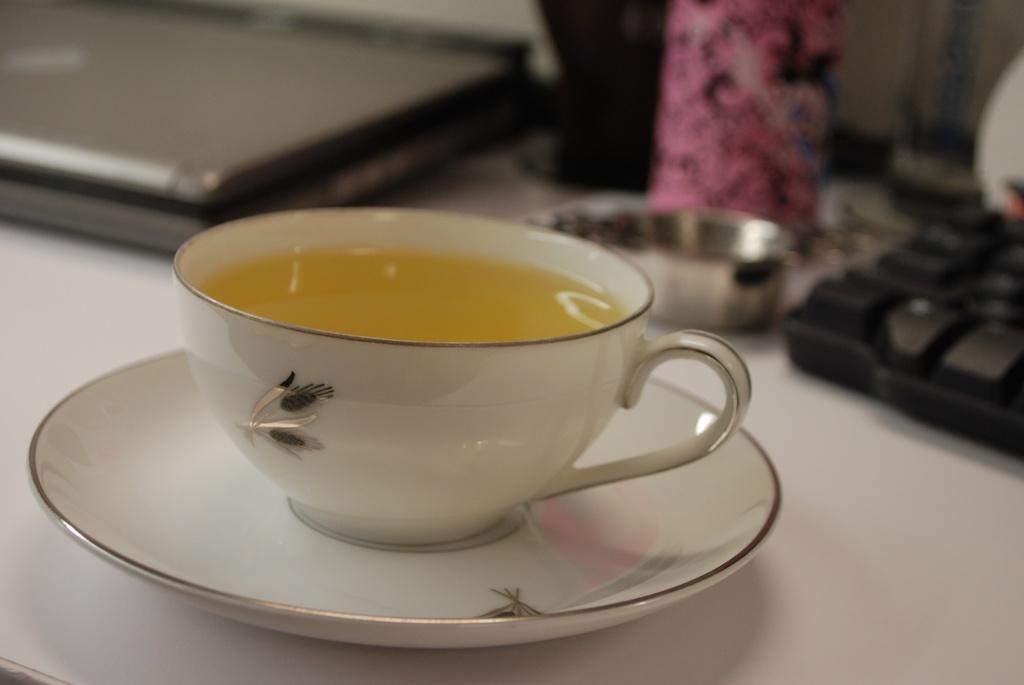What is on the saucer in the image? There is a cup with liquid in it on a saucer. Where is the cup and saucer located? The cup and saucer are on a table. What electronic device is present in the image? There is a laptop in the image. What type of objects can be seen in the image? There are objects in the image, including a cup, saucer, and laptop. What might be used for typing in the image? There is a keyboard in the image. What songs can be heard playing from the snake in the image? There is no snake present in the image, and therefore no songs can be heard. 